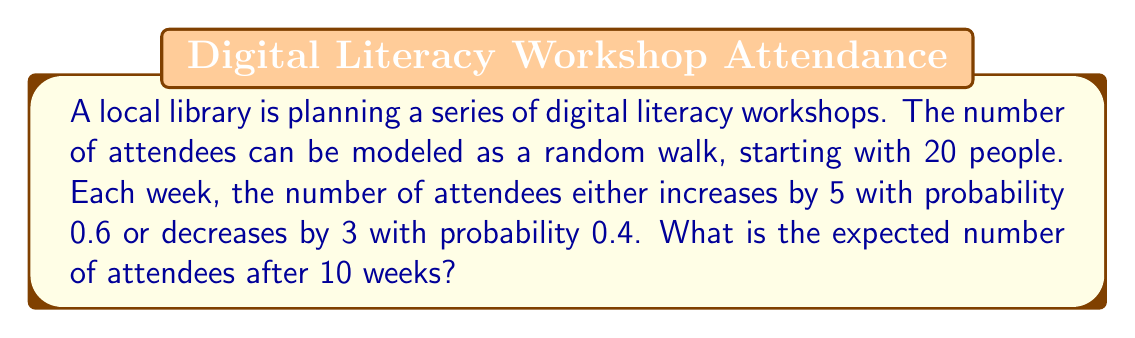Can you answer this question? Let's approach this step-by-step:

1) In a random walk model, we need to calculate the expected change in each step. 

2) The expected change per week is:
   $$ E[\text{change}] = 5 \cdot 0.6 + (-3) \cdot 0.4 = 3 - 1.2 = 1.8 $$

3) Over 10 weeks, the expected total change is:
   $$ E[\text{total change}] = 1.8 \cdot 10 = 18 $$

4) The initial number of attendees is 20, so after 10 weeks, the expected number is:
   $$ E[\text{attendees after 10 weeks}] = 20 + 18 = 38 $$

5) Therefore, the expected number of attendees after 10 weeks is 38.

Note: This is a simplified model. In reality, attendance might be influenced by many other factors not captured in this random walk model.
Answer: 38 attendees 